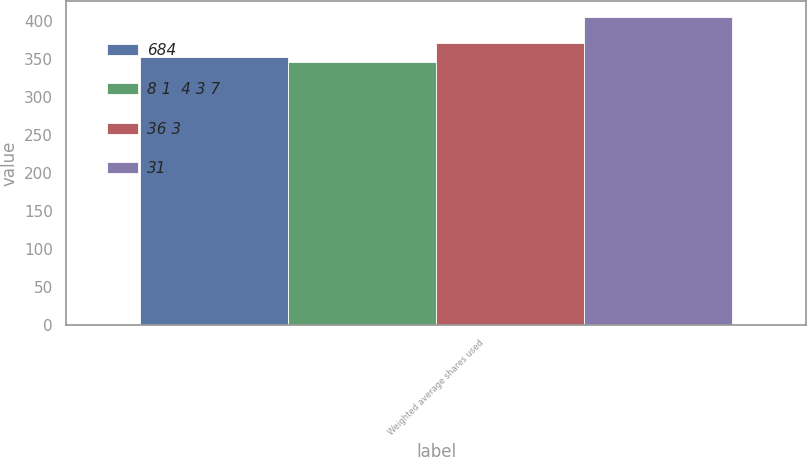Convert chart to OTSL. <chart><loc_0><loc_0><loc_500><loc_500><stacked_bar_chart><ecel><fcel>Weighted average shares used<nl><fcel>684<fcel>353<nl><fcel>8 1  4 3 7<fcel>346<nl><fcel>36 3<fcel>371<nl><fcel>31<fcel>406<nl></chart> 